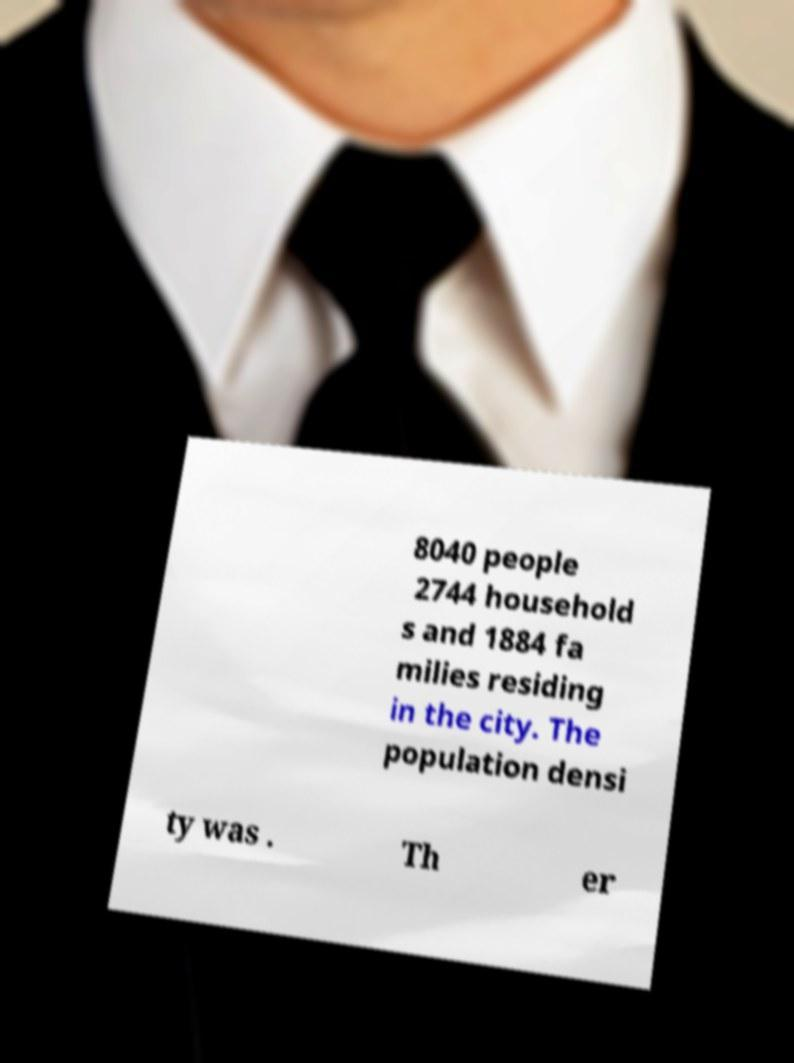What messages or text are displayed in this image? I need them in a readable, typed format. 8040 people 2744 household s and 1884 fa milies residing in the city. The population densi ty was . Th er 